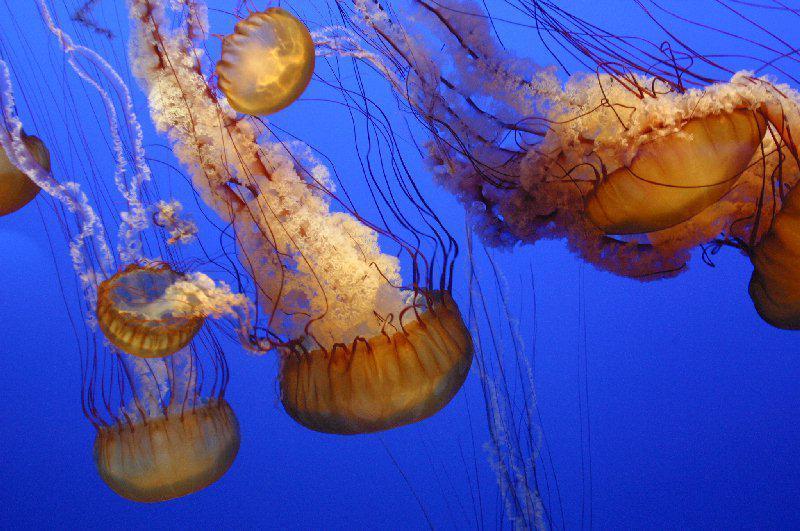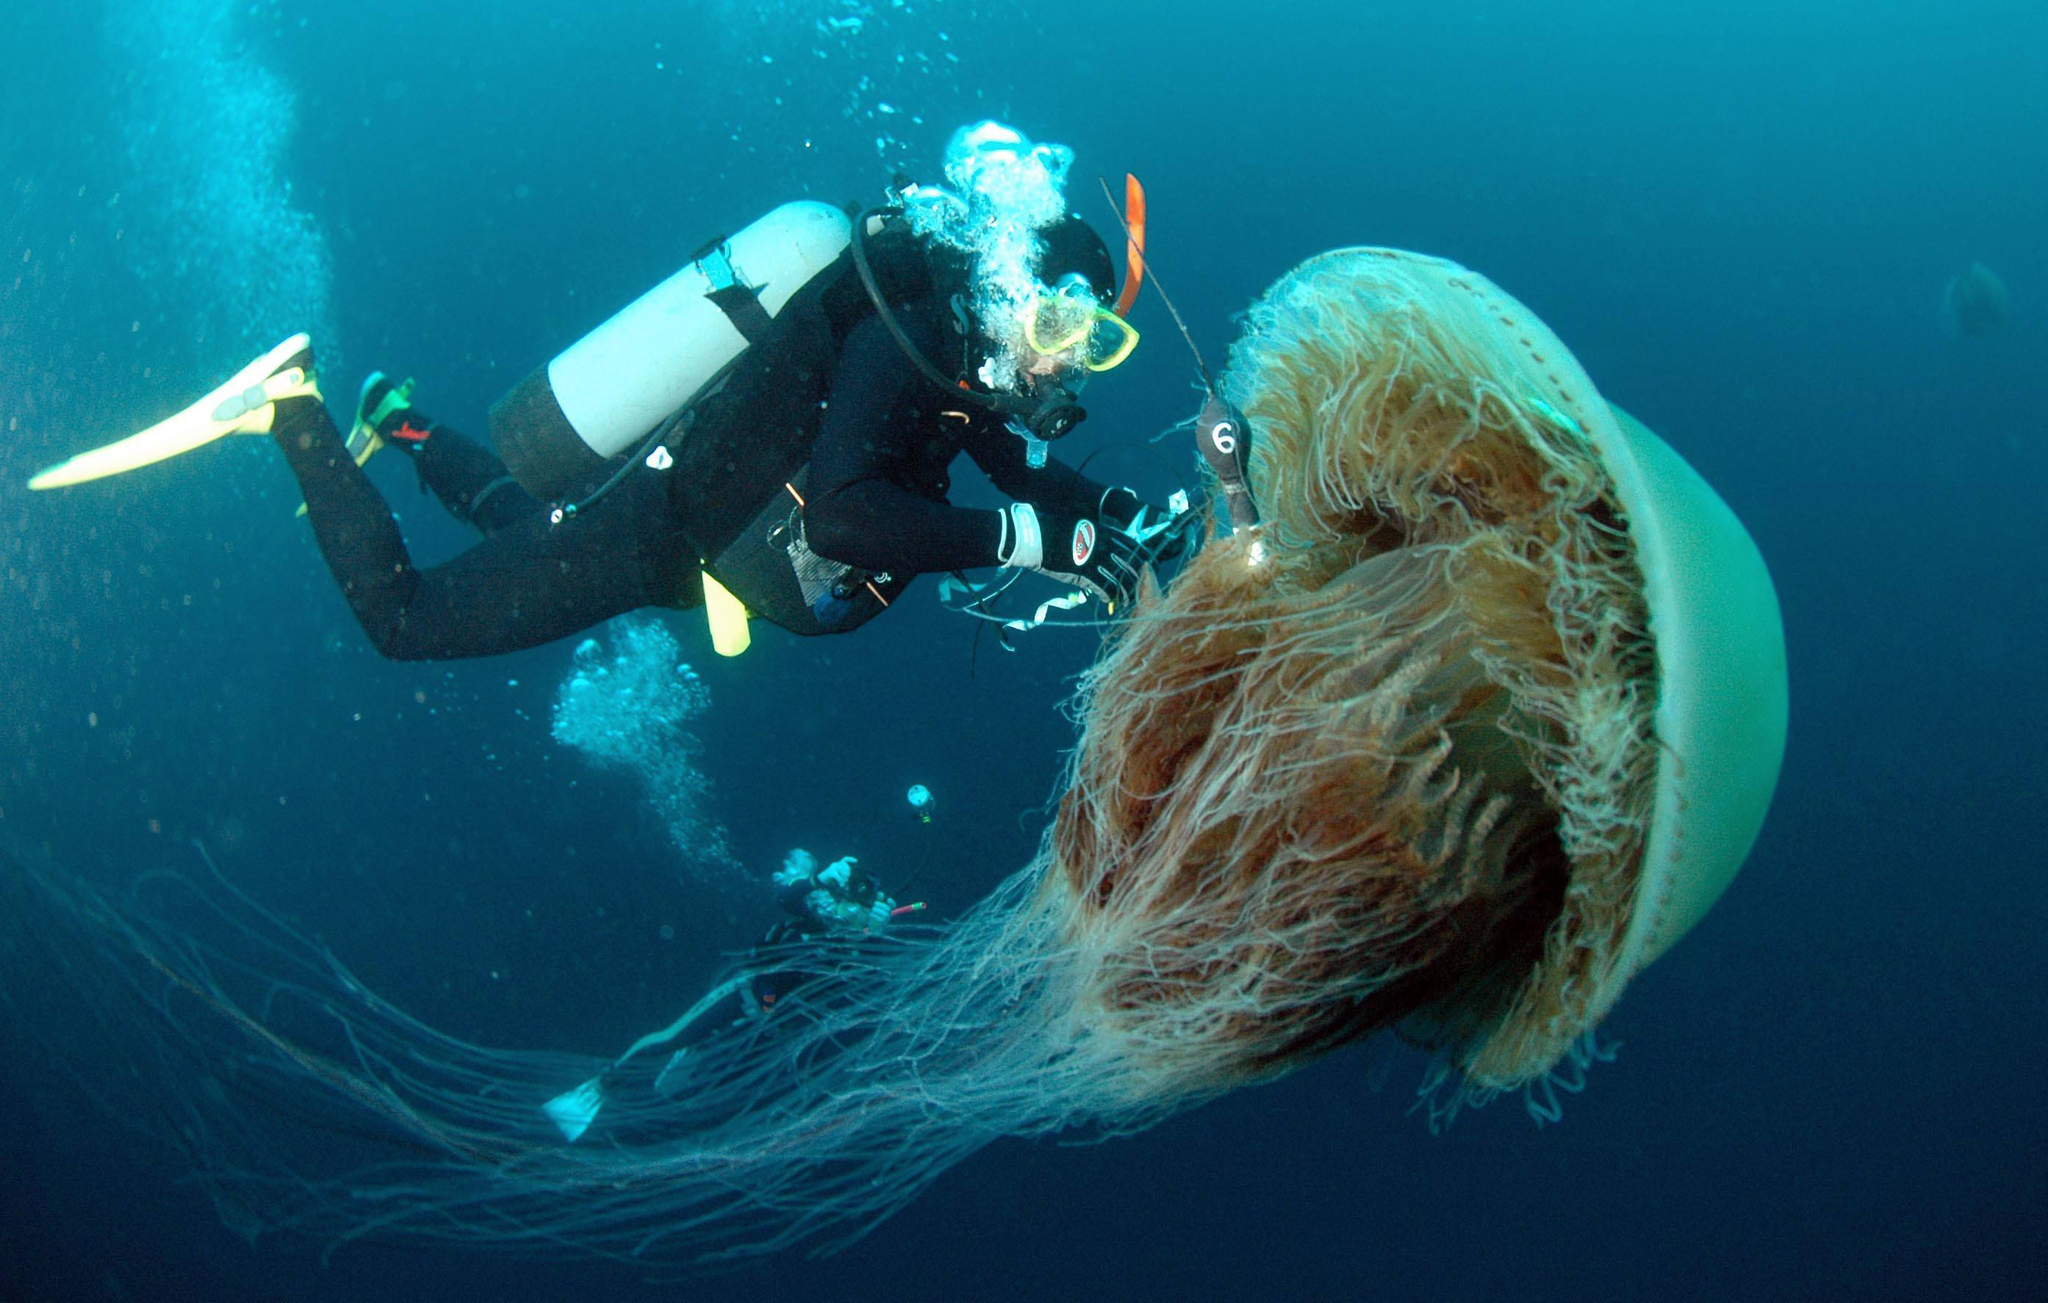The first image is the image on the left, the second image is the image on the right. Evaluate the accuracy of this statement regarding the images: "One of the images has a person in the lwater with the sting rays.". Is it true? Answer yes or no. Yes. The first image is the image on the left, the second image is the image on the right. Assess this claim about the two images: "The surface of the water is visible.". Correct or not? Answer yes or no. No. 